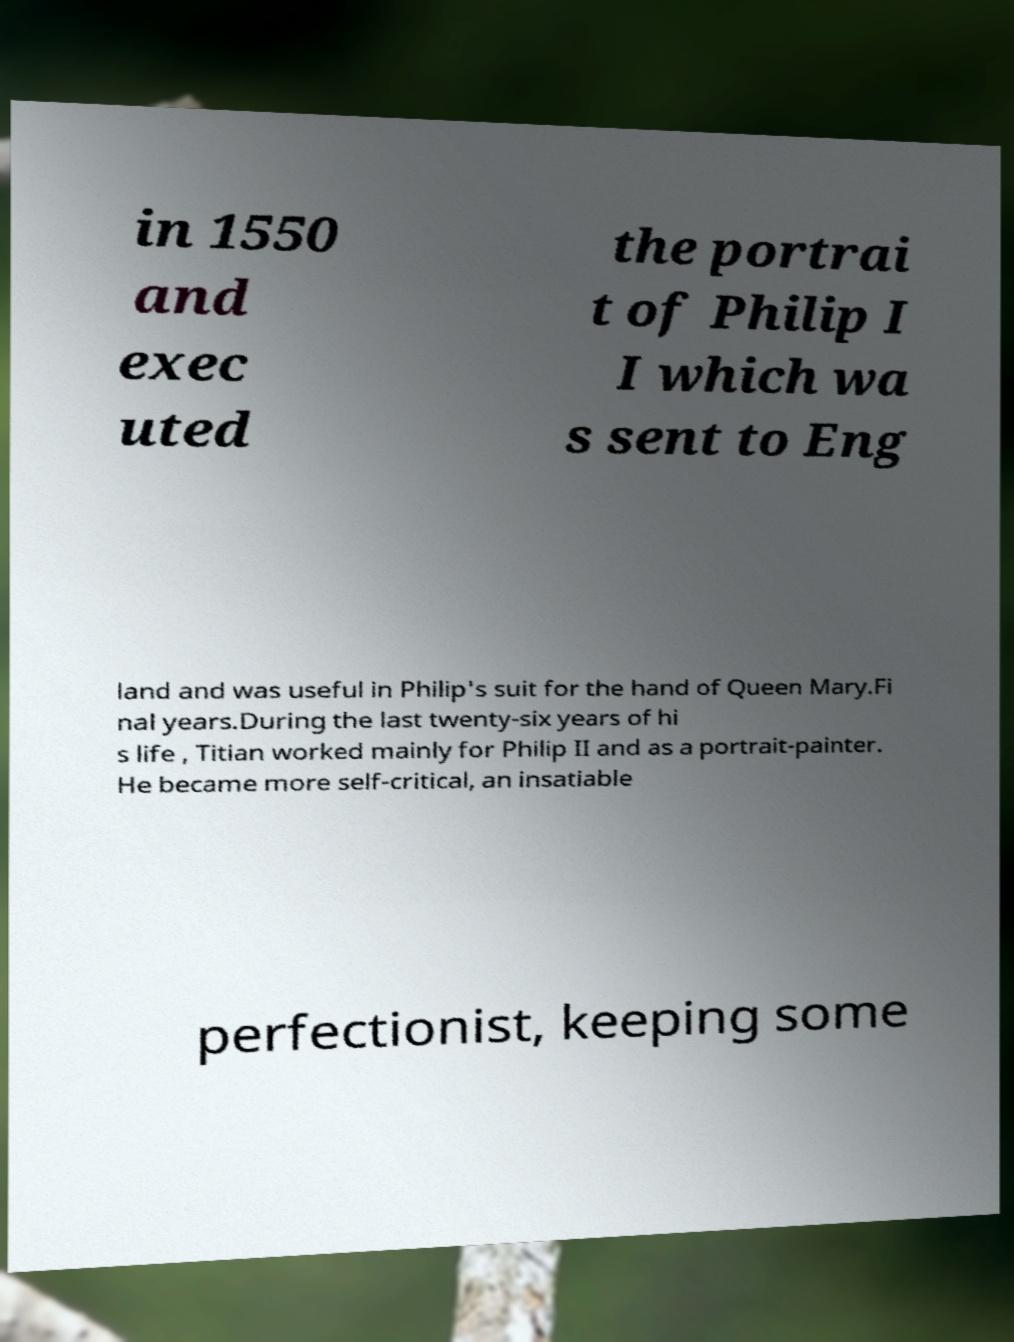Could you assist in decoding the text presented in this image and type it out clearly? in 1550 and exec uted the portrai t of Philip I I which wa s sent to Eng land and was useful in Philip's suit for the hand of Queen Mary.Fi nal years.During the last twenty-six years of hi s life , Titian worked mainly for Philip II and as a portrait-painter. He became more self-critical, an insatiable perfectionist, keeping some 